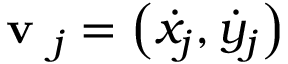<formula> <loc_0><loc_0><loc_500><loc_500>v _ { j } = \left ( \dot { x } _ { j } , \dot { y } _ { j } \right )</formula> 